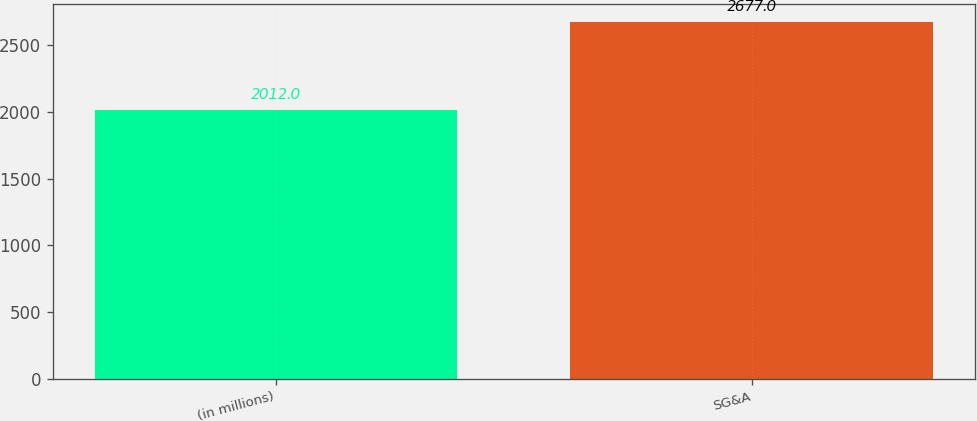Convert chart to OTSL. <chart><loc_0><loc_0><loc_500><loc_500><bar_chart><fcel>(in millions)<fcel>SG&A<nl><fcel>2012<fcel>2677<nl></chart> 